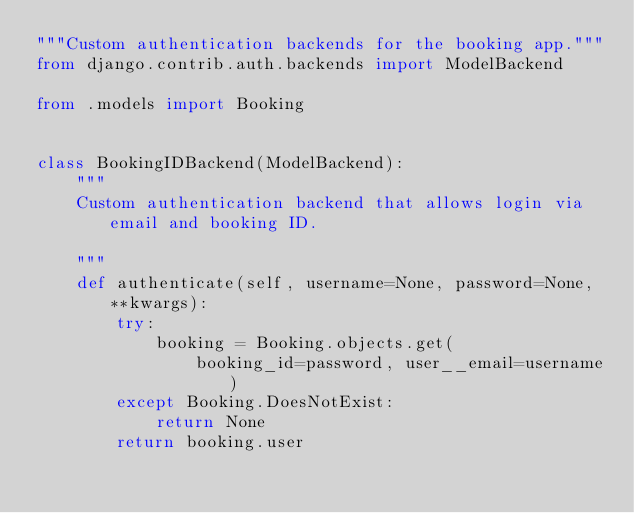<code> <loc_0><loc_0><loc_500><loc_500><_Python_>"""Custom authentication backends for the booking app."""
from django.contrib.auth.backends import ModelBackend

from .models import Booking


class BookingIDBackend(ModelBackend):
    """
    Custom authentication backend that allows login via email and booking ID.

    """
    def authenticate(self, username=None, password=None, **kwargs):
        try:
            booking = Booking.objects.get(
                booking_id=password, user__email=username)
        except Booking.DoesNotExist:
            return None
        return booking.user
</code> 